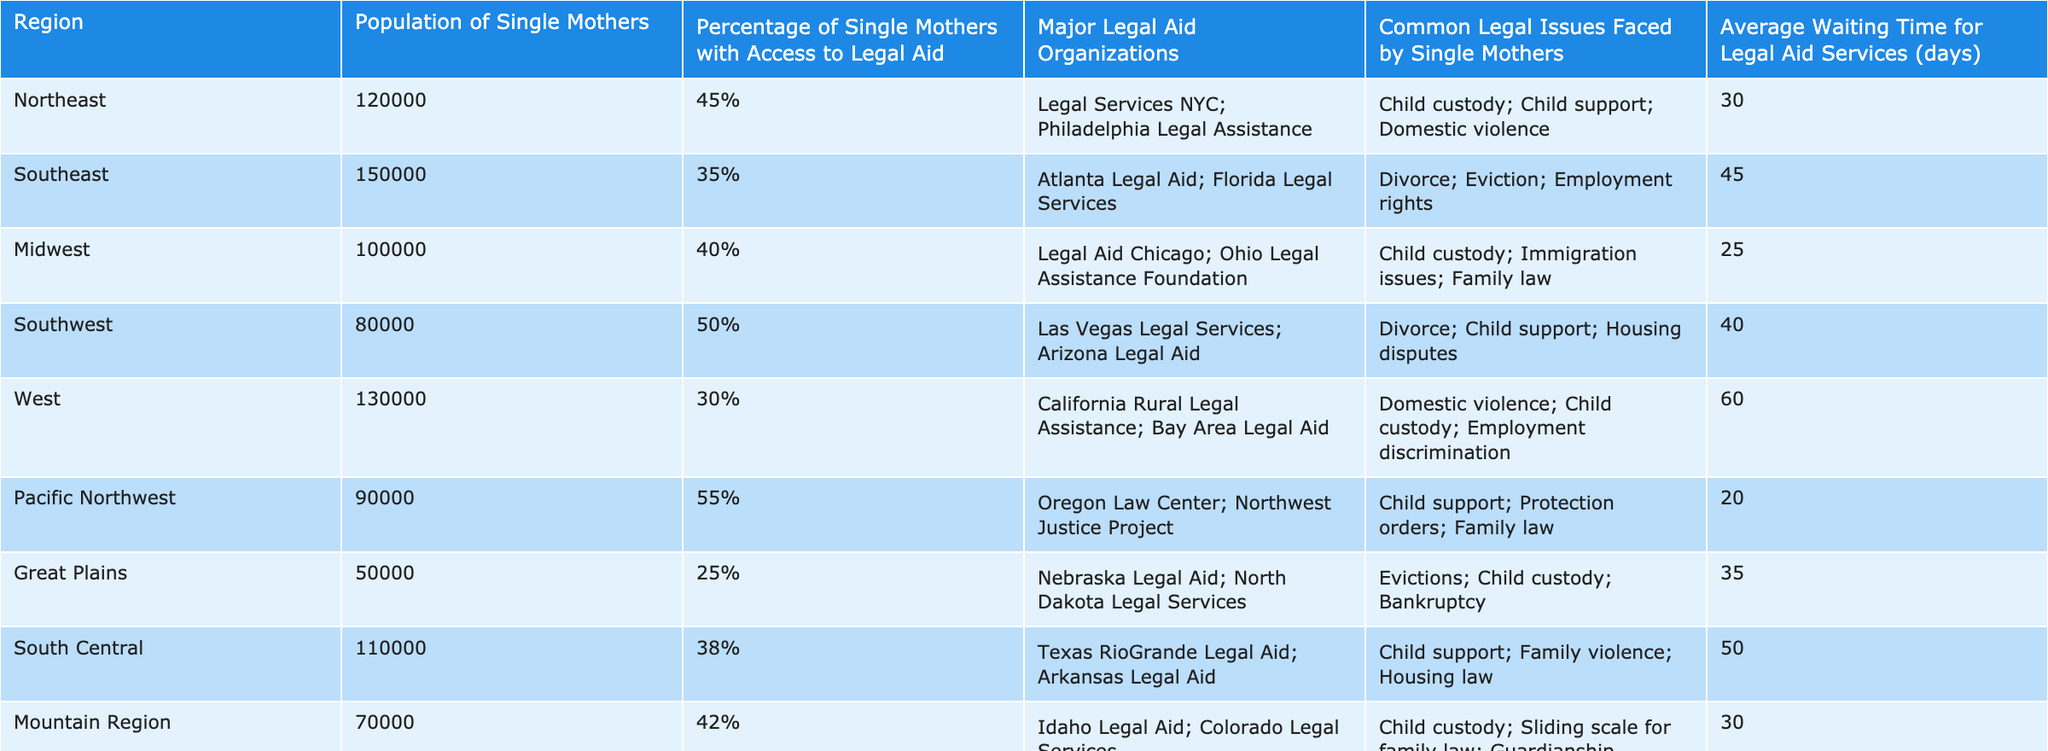What region has the highest percentage of single mothers with access to legal aid? By examining the "Percentage of Single Mothers with Access to Legal Aid" column in the table, I find that the Pacific Northwest has the highest value at 55%.
Answer: Pacific Northwest Which region has the lowest number of single mothers? Checking the "Population of Single Mothers" column, the Great Plains region has the lowest population at 50,000 single mothers.
Answer: Great Plains What is the average waiting time for legal aid services across all regions? I calculate the average waiting time by summing the waiting times from all regions (30 + 45 + 25 + 40 + 60 + 20 + 35 + 50 + 30 + 55 = 415) and dividing by the number of regions (10), giving an average waiting time of 415/10 = 41.5 days.
Answer: 41.5 days Are the major legal aid organizations the same in all regions? By comparing the "Major Legal Aid Organizations" column across regions, it's clear that they vary and are unique to each region.
Answer: No Which region reports the most common legal issues faced by single mothers? I analyze the "Common Legal Issues Faced by Single Mothers" column and note that while many regions have overlapping issues, child custody is a frequent mention in several regions, notably Northeast and Midwest, but each region has unique issues listed as well.
Answer: Various issues reported across regions, no single most common issue What is the percentage difference in access to legal aid between the Northeast and the Southeast regions? The Northeast has 45% access, while the Southeast has 35%, leading to a difference of 45% - 35% = 10%.
Answer: 10% In which regions do single mothers face domestic violence as a common legal issue? I examine the "Common Legal Issues Faced by Single Mothers" column, finding that Northeast, West, and Appalachia all list domestic violence among the issues.
Answer: Northeast, West, Appalachia Which region has a longer waiting time for legal aid services, and by how many days compared to the next longest? The West region has the longest waiting time of 60 days, and the South Central region has 50 days. The difference is 60 - 50 = 10 days.
Answer: West region, 10 days longer What is the total population of single mothers in the Midwest and South Central regions combined? I sum the populations of single mothers in both regions: 100,000 (Midwest) + 110,000 (South Central) = 210,000.
Answer: 210,000 Is the average waiting time for legal aid services shorter in the Pacific Northwest compared to the South East? The Pacific Northwest has a waiting time of 20 days while the Southeast has 45 days, making it evident that the Pacific Northwest's waiting time is significantly shorter.
Answer: Yes, it is shorter 